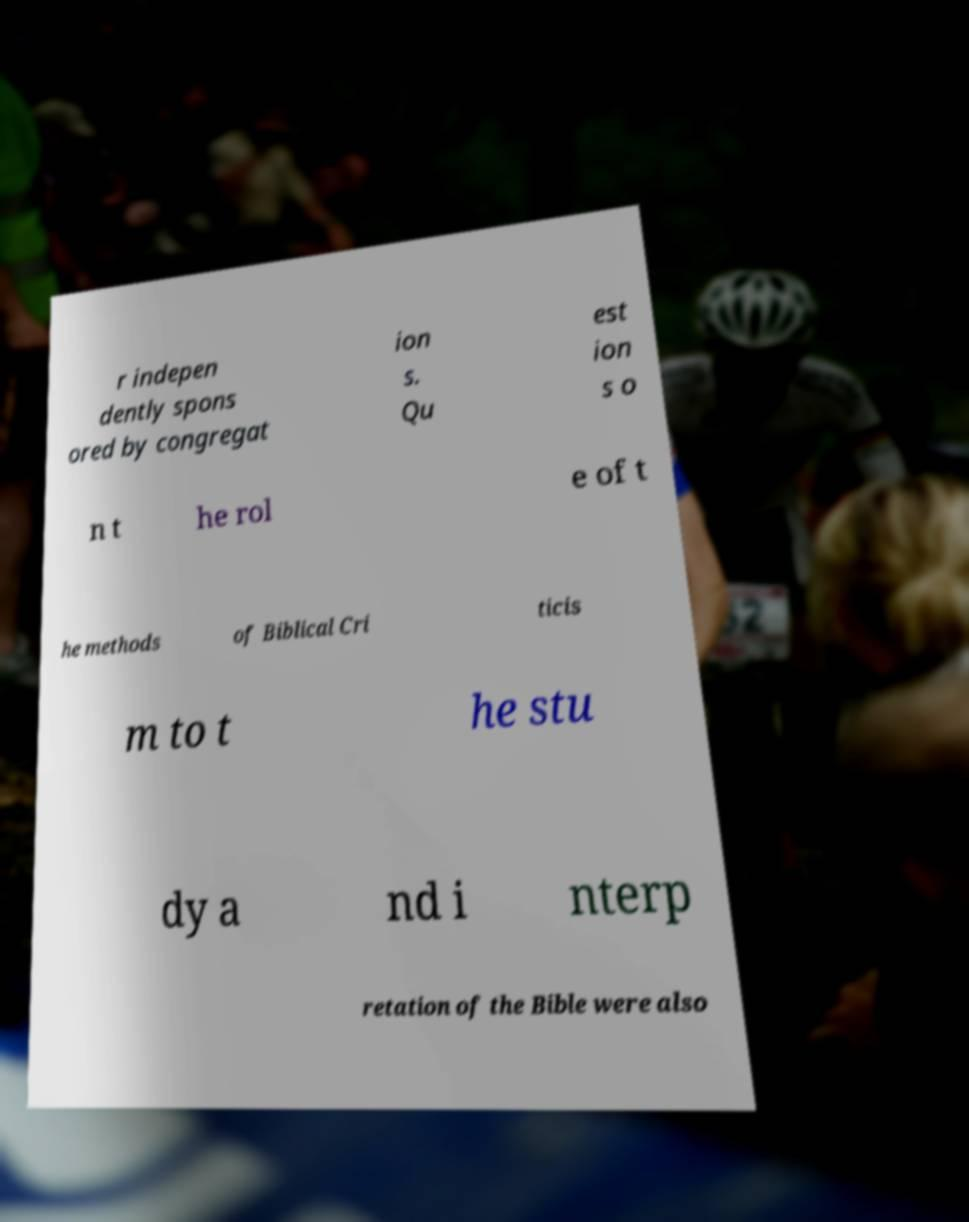Can you accurately transcribe the text from the provided image for me? r indepen dently spons ored by congregat ion s. Qu est ion s o n t he rol e of t he methods of Biblical Cri ticis m to t he stu dy a nd i nterp retation of the Bible were also 